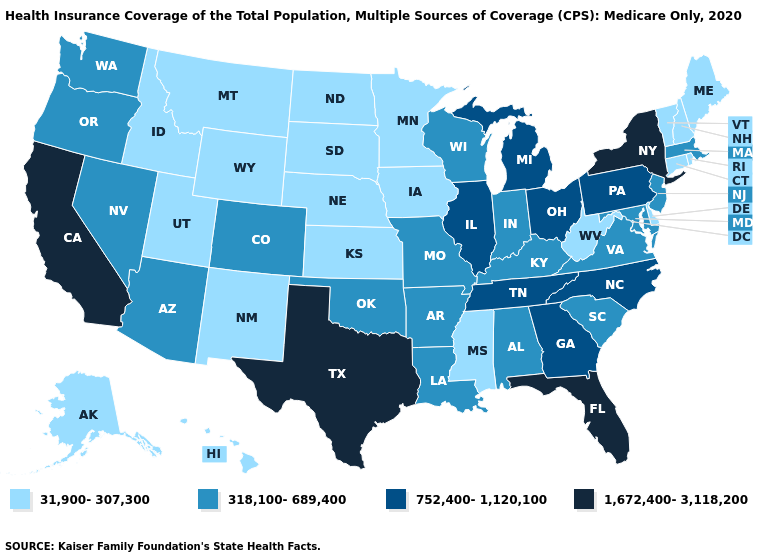What is the lowest value in states that border Massachusetts?
Give a very brief answer. 31,900-307,300. What is the value of Arkansas?
Write a very short answer. 318,100-689,400. What is the lowest value in states that border Nebraska?
Short answer required. 31,900-307,300. What is the highest value in states that border Nebraska?
Be succinct. 318,100-689,400. Does North Carolina have the highest value in the USA?
Give a very brief answer. No. Which states have the highest value in the USA?
Concise answer only. California, Florida, New York, Texas. What is the value of Virginia?
Quick response, please. 318,100-689,400. What is the highest value in the West ?
Quick response, please. 1,672,400-3,118,200. What is the value of Wisconsin?
Quick response, please. 318,100-689,400. Among the states that border New Mexico , does Utah have the lowest value?
Short answer required. Yes. What is the value of Oregon?
Short answer required. 318,100-689,400. Name the states that have a value in the range 318,100-689,400?
Give a very brief answer. Alabama, Arizona, Arkansas, Colorado, Indiana, Kentucky, Louisiana, Maryland, Massachusetts, Missouri, Nevada, New Jersey, Oklahoma, Oregon, South Carolina, Virginia, Washington, Wisconsin. Which states have the lowest value in the USA?
Concise answer only. Alaska, Connecticut, Delaware, Hawaii, Idaho, Iowa, Kansas, Maine, Minnesota, Mississippi, Montana, Nebraska, New Hampshire, New Mexico, North Dakota, Rhode Island, South Dakota, Utah, Vermont, West Virginia, Wyoming. Name the states that have a value in the range 31,900-307,300?
Concise answer only. Alaska, Connecticut, Delaware, Hawaii, Idaho, Iowa, Kansas, Maine, Minnesota, Mississippi, Montana, Nebraska, New Hampshire, New Mexico, North Dakota, Rhode Island, South Dakota, Utah, Vermont, West Virginia, Wyoming. 